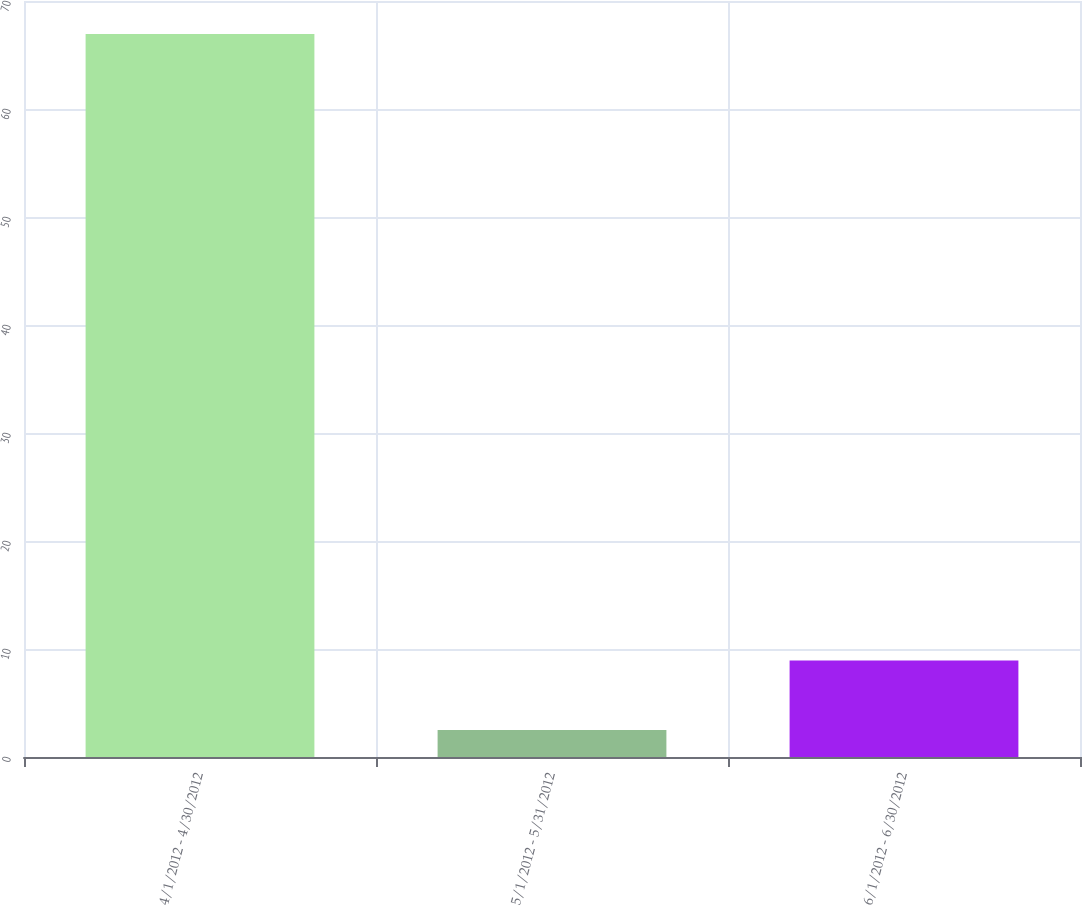Convert chart to OTSL. <chart><loc_0><loc_0><loc_500><loc_500><bar_chart><fcel>4/1/2012 - 4/30/2012<fcel>5/1/2012 - 5/31/2012<fcel>6/1/2012 - 6/30/2012<nl><fcel>66.95<fcel>2.49<fcel>8.94<nl></chart> 